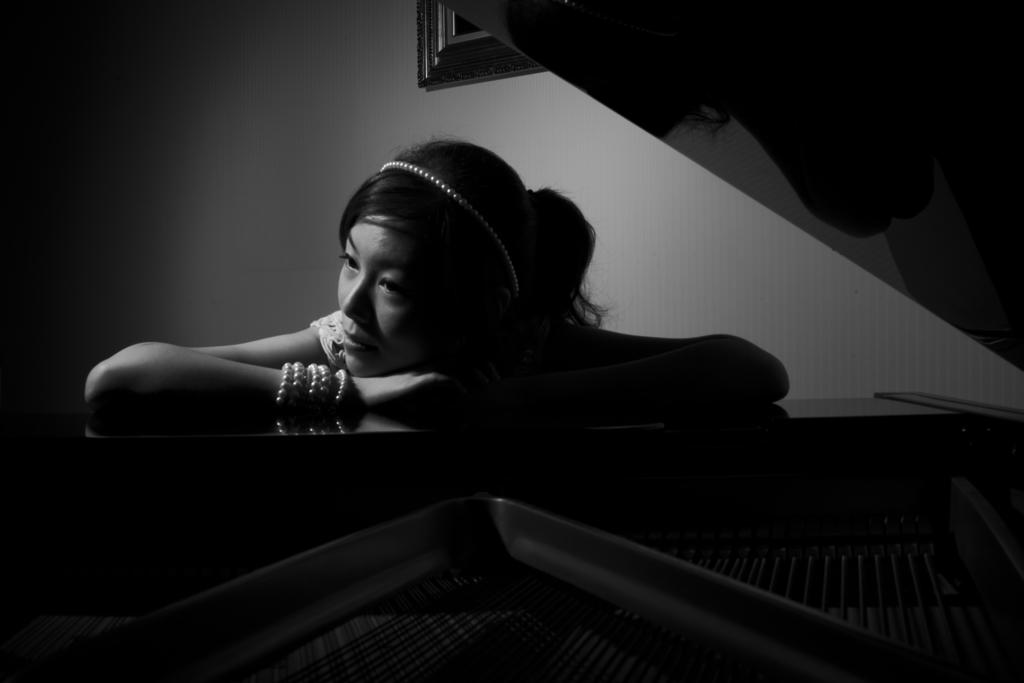Who is present in the picture? There is a woman in the picture. What is the woman wearing on her wrist? The woman is wearing a bracelet. What color is the dress the woman is wearing? The woman is wearing a white dress. What object is the woman sitting near? The woman is sitting near a piano. What can be seen on the wall in the picture? There is a frame on the wall in the picture. What day of the week is depicted in the image? The image does not depict a day of the week; it features a woman sitting near a piano. Can you see a leaf on the floor in the image? There is no leaf visible on the floor in the image. 